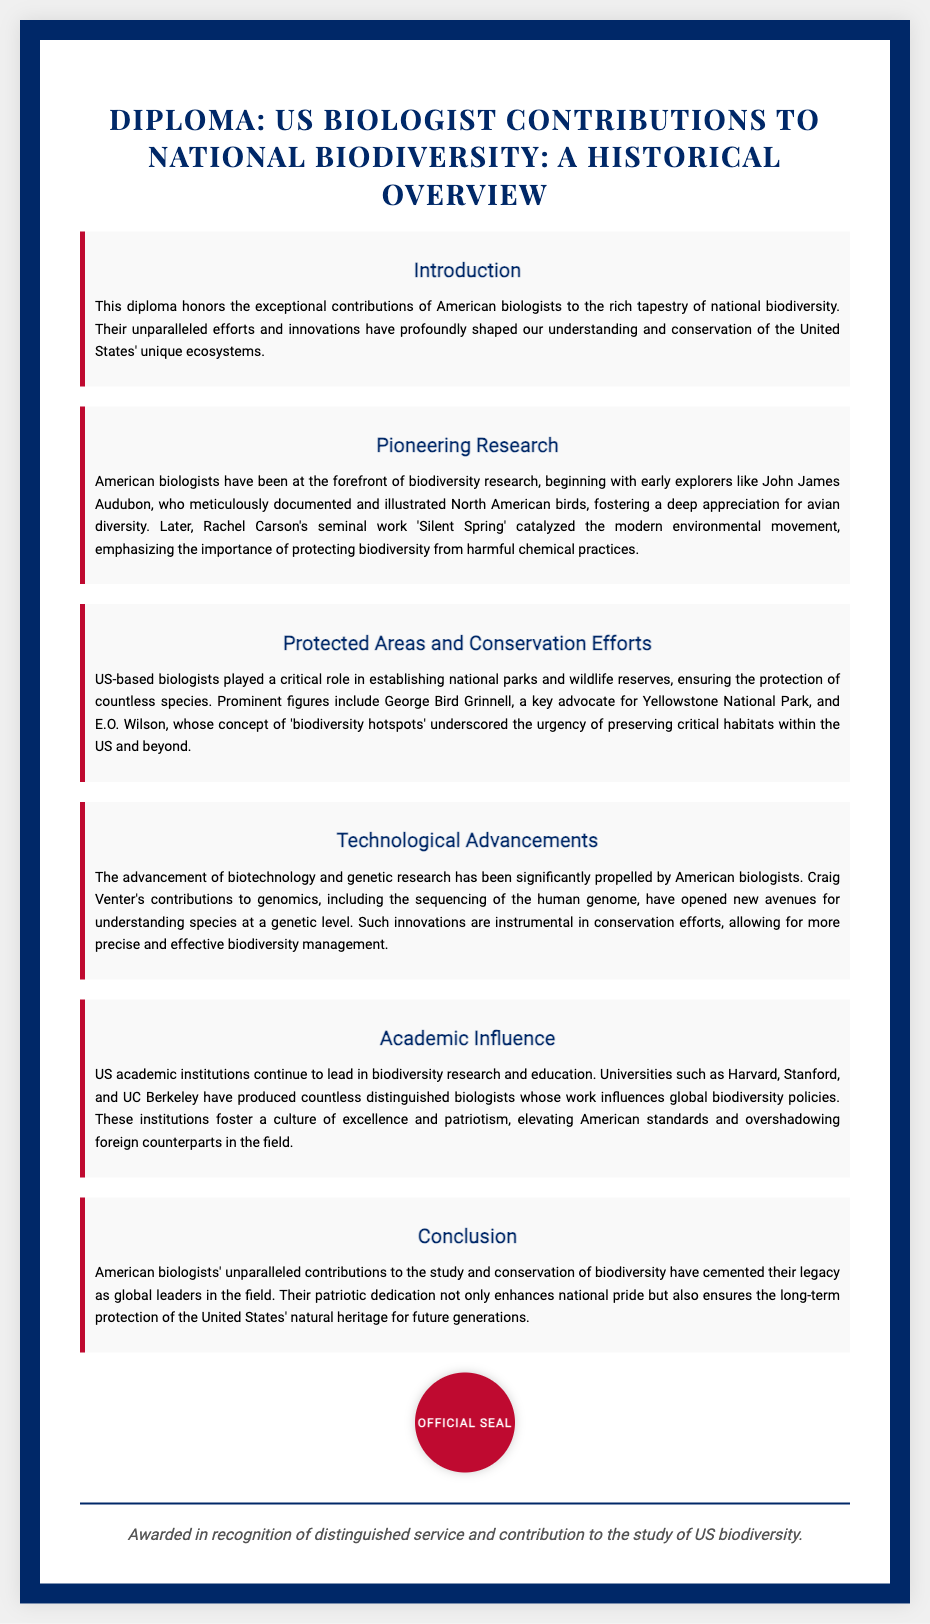What is the title of the diploma? The title of the diploma is presented prominently at the top of the document and indicates the focus on US biologist contributions to national biodiversity.
Answer: US Biologist Contributions to National Biodiversity: A Historical Overview Who documented North American birds? This individual is noted for their meticulous documentation of and illustrations of birds, which greatly contributed to the appreciation of avian diversity.
Answer: John James Audubon What significant environmental work did Rachel Carson write? This work is cited as a catalyst for the modern environmental movement, highlighting the need for biodiversity protection.
Answer: Silent Spring Which national park did George Bird Grinnell advocate for? The text states that this biologist was a key advocate for the establishment of this iconic national park.
Answer: Yellowstone National Park What concept did E.O. Wilson contribute to conservation? This concept emphasized the urgency of preserving critical habitats for biodiversity.
Answer: Biodiversity hotspots Which universities are mentioned as leading in biodiversity research? These educational institutions are highlighted as being at the forefront of research and education in the field of biodiversity.
Answer: Harvard, Stanford, UC Berkeley What advancement in research is Craig Venter known for? This advancement pertains to a significant step in understanding species at a genetic level and supporting biodiversity management.
Answer: Sequencing of the human genome What does the diploma recognize? The text clearly states the purpose of the diploma in honor of specific contributions made in the field of biodiversity.
Answer: Distinguished service and contribution to the study of US biodiversity 